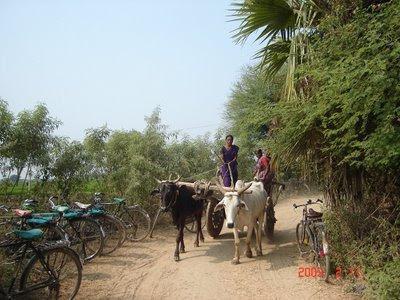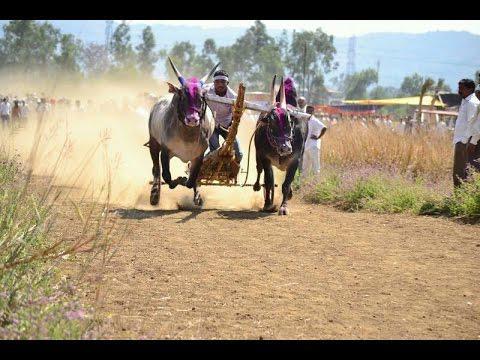The first image is the image on the left, the second image is the image on the right. For the images displayed, is the sentence "Four oxen are pulling carts with at least one person riding in them." factually correct? Answer yes or no. Yes. The first image is the image on the left, the second image is the image on the right. Examine the images to the left and right. Is the description "The oxen in the image on the right are wearing decorative headgear." accurate? Answer yes or no. Yes. 